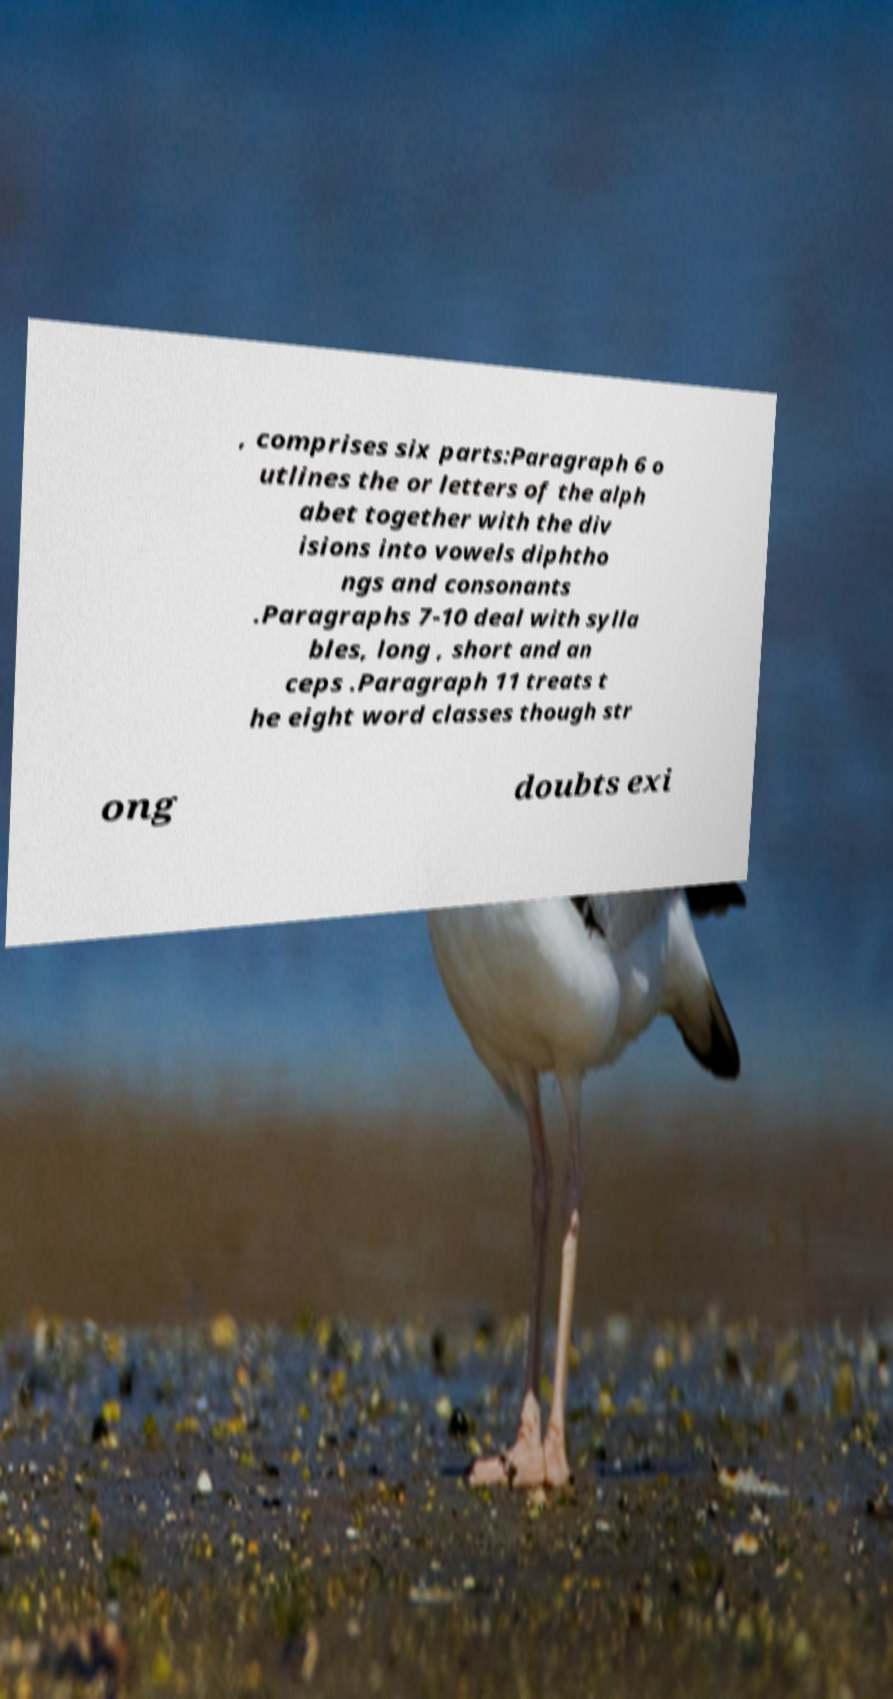Could you assist in decoding the text presented in this image and type it out clearly? , comprises six parts:Paragraph 6 o utlines the or letters of the alph abet together with the div isions into vowels diphtho ngs and consonants .Paragraphs 7-10 deal with sylla bles, long , short and an ceps .Paragraph 11 treats t he eight word classes though str ong doubts exi 